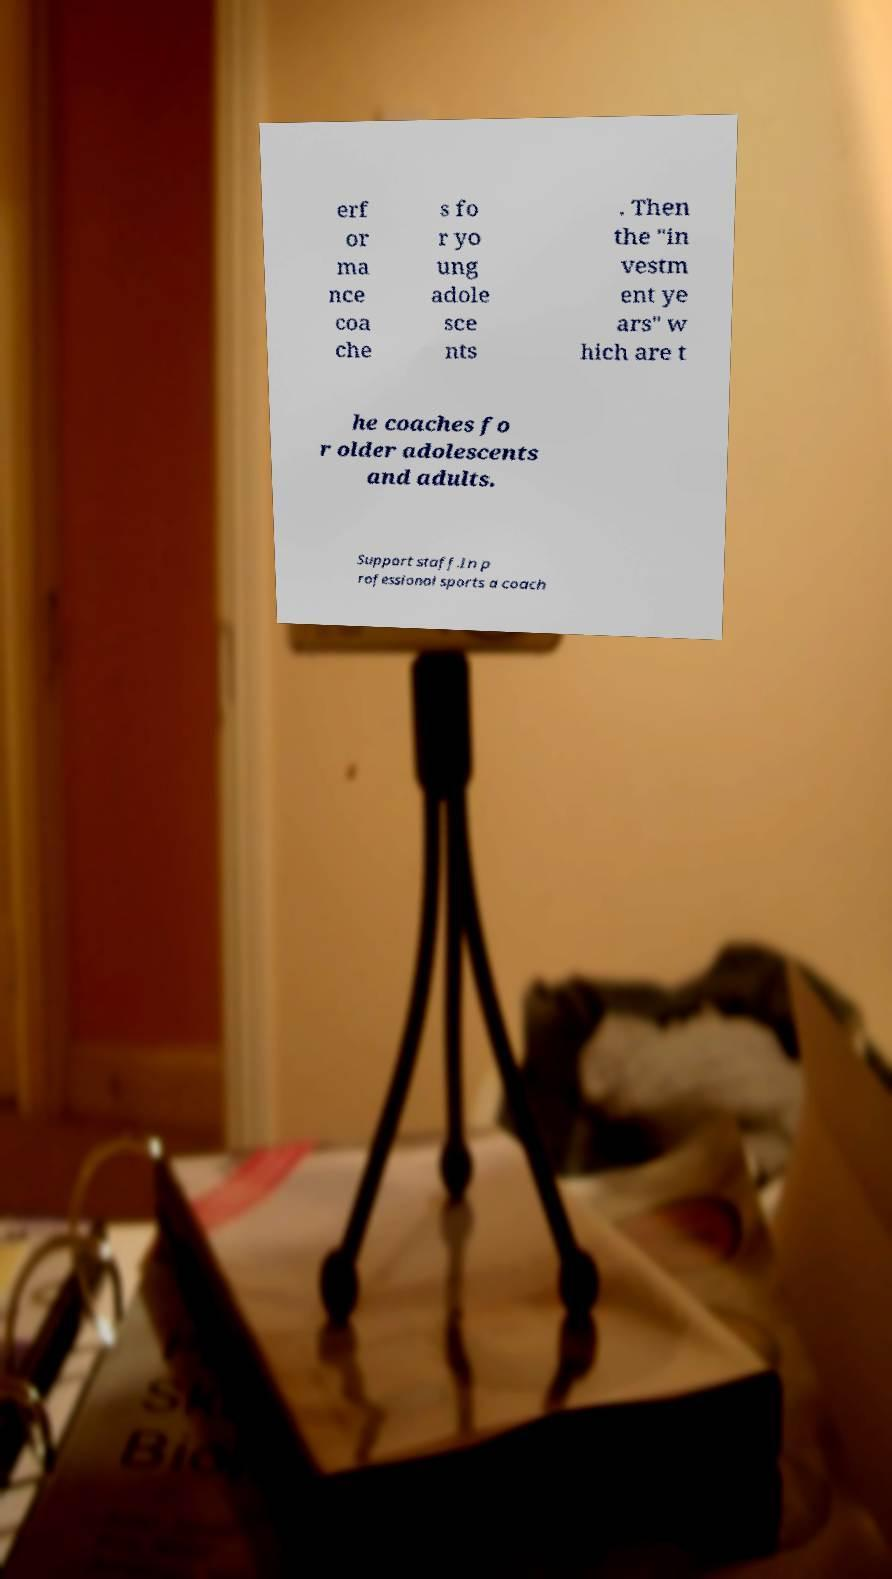Please read and relay the text visible in this image. What does it say? erf or ma nce coa che s fo r yo ung adole sce nts . Then the "in vestm ent ye ars" w hich are t he coaches fo r older adolescents and adults. Support staff.In p rofessional sports a coach 